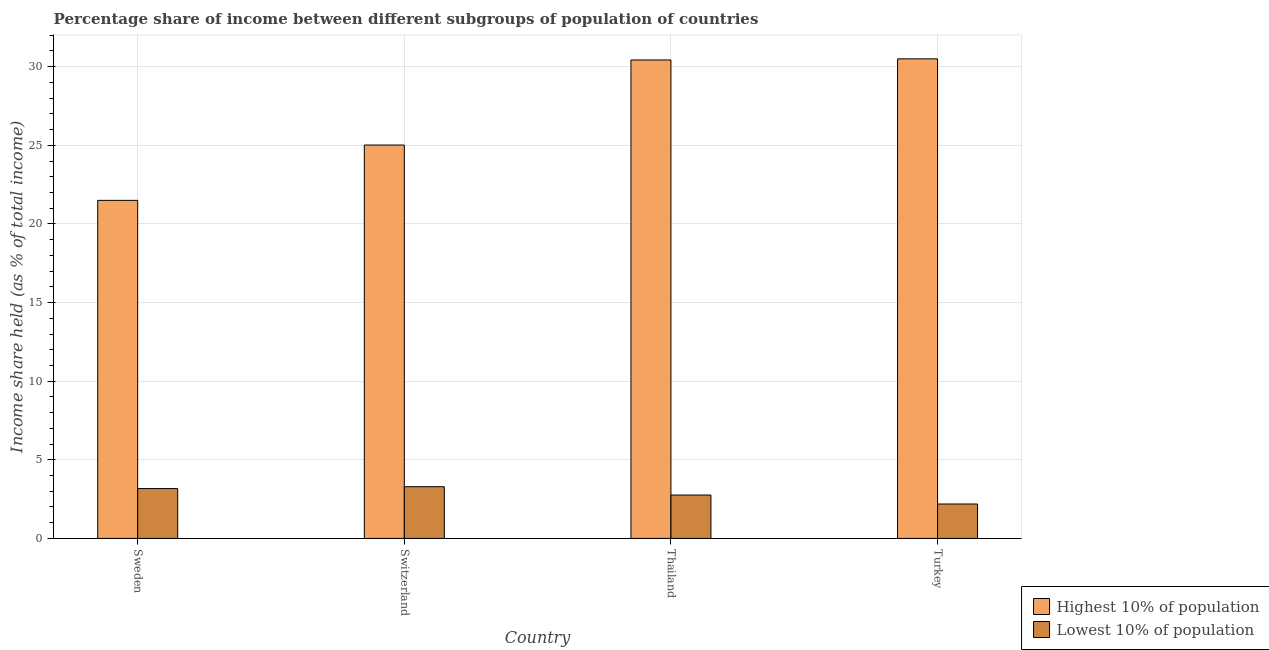Are the number of bars on each tick of the X-axis equal?
Your response must be concise. Yes. How many bars are there on the 2nd tick from the left?
Make the answer very short. 2. How many bars are there on the 3rd tick from the right?
Keep it short and to the point. 2. In how many cases, is the number of bars for a given country not equal to the number of legend labels?
Your answer should be compact. 0. What is the income share held by highest 10% of the population in Turkey?
Provide a short and direct response. 30.5. Across all countries, what is the maximum income share held by highest 10% of the population?
Provide a succinct answer. 30.5. Across all countries, what is the minimum income share held by highest 10% of the population?
Offer a very short reply. 21.5. In which country was the income share held by lowest 10% of the population minimum?
Your response must be concise. Turkey. What is the total income share held by lowest 10% of the population in the graph?
Ensure brevity in your answer.  11.41. What is the difference between the income share held by highest 10% of the population in Switzerland and that in Thailand?
Give a very brief answer. -5.41. What is the difference between the income share held by lowest 10% of the population in Switzerland and the income share held by highest 10% of the population in Turkey?
Your answer should be very brief. -27.21. What is the average income share held by highest 10% of the population per country?
Provide a succinct answer. 26.86. What is the difference between the income share held by lowest 10% of the population and income share held by highest 10% of the population in Sweden?
Offer a terse response. -18.33. In how many countries, is the income share held by lowest 10% of the population greater than 19 %?
Keep it short and to the point. 0. What is the ratio of the income share held by lowest 10% of the population in Sweden to that in Turkey?
Keep it short and to the point. 1.45. What is the difference between the highest and the second highest income share held by lowest 10% of the population?
Make the answer very short. 0.12. In how many countries, is the income share held by lowest 10% of the population greater than the average income share held by lowest 10% of the population taken over all countries?
Your answer should be very brief. 2. Is the sum of the income share held by lowest 10% of the population in Thailand and Turkey greater than the maximum income share held by highest 10% of the population across all countries?
Ensure brevity in your answer.  No. What does the 1st bar from the left in Sweden represents?
Ensure brevity in your answer.  Highest 10% of population. What does the 1st bar from the right in Sweden represents?
Your answer should be compact. Lowest 10% of population. How many countries are there in the graph?
Provide a succinct answer. 4. Are the values on the major ticks of Y-axis written in scientific E-notation?
Your answer should be compact. No. What is the title of the graph?
Provide a succinct answer. Percentage share of income between different subgroups of population of countries. Does "Secondary education" appear as one of the legend labels in the graph?
Your answer should be compact. No. What is the label or title of the X-axis?
Keep it short and to the point. Country. What is the label or title of the Y-axis?
Offer a very short reply. Income share held (as % of total income). What is the Income share held (as % of total income) of Highest 10% of population in Sweden?
Ensure brevity in your answer.  21.5. What is the Income share held (as % of total income) in Lowest 10% of population in Sweden?
Your answer should be very brief. 3.17. What is the Income share held (as % of total income) in Highest 10% of population in Switzerland?
Keep it short and to the point. 25.02. What is the Income share held (as % of total income) in Lowest 10% of population in Switzerland?
Give a very brief answer. 3.29. What is the Income share held (as % of total income) in Highest 10% of population in Thailand?
Your response must be concise. 30.43. What is the Income share held (as % of total income) of Lowest 10% of population in Thailand?
Your answer should be compact. 2.76. What is the Income share held (as % of total income) in Highest 10% of population in Turkey?
Your answer should be very brief. 30.5. What is the Income share held (as % of total income) of Lowest 10% of population in Turkey?
Offer a terse response. 2.19. Across all countries, what is the maximum Income share held (as % of total income) in Highest 10% of population?
Make the answer very short. 30.5. Across all countries, what is the maximum Income share held (as % of total income) of Lowest 10% of population?
Ensure brevity in your answer.  3.29. Across all countries, what is the minimum Income share held (as % of total income) in Highest 10% of population?
Offer a terse response. 21.5. Across all countries, what is the minimum Income share held (as % of total income) in Lowest 10% of population?
Give a very brief answer. 2.19. What is the total Income share held (as % of total income) in Highest 10% of population in the graph?
Keep it short and to the point. 107.45. What is the total Income share held (as % of total income) of Lowest 10% of population in the graph?
Make the answer very short. 11.41. What is the difference between the Income share held (as % of total income) in Highest 10% of population in Sweden and that in Switzerland?
Provide a succinct answer. -3.52. What is the difference between the Income share held (as % of total income) of Lowest 10% of population in Sweden and that in Switzerland?
Make the answer very short. -0.12. What is the difference between the Income share held (as % of total income) of Highest 10% of population in Sweden and that in Thailand?
Your answer should be very brief. -8.93. What is the difference between the Income share held (as % of total income) in Lowest 10% of population in Sweden and that in Thailand?
Your answer should be compact. 0.41. What is the difference between the Income share held (as % of total income) of Highest 10% of population in Switzerland and that in Thailand?
Make the answer very short. -5.41. What is the difference between the Income share held (as % of total income) in Lowest 10% of population in Switzerland and that in Thailand?
Keep it short and to the point. 0.53. What is the difference between the Income share held (as % of total income) in Highest 10% of population in Switzerland and that in Turkey?
Keep it short and to the point. -5.48. What is the difference between the Income share held (as % of total income) of Highest 10% of population in Thailand and that in Turkey?
Provide a succinct answer. -0.07. What is the difference between the Income share held (as % of total income) in Lowest 10% of population in Thailand and that in Turkey?
Ensure brevity in your answer.  0.57. What is the difference between the Income share held (as % of total income) of Highest 10% of population in Sweden and the Income share held (as % of total income) of Lowest 10% of population in Switzerland?
Keep it short and to the point. 18.21. What is the difference between the Income share held (as % of total income) of Highest 10% of population in Sweden and the Income share held (as % of total income) of Lowest 10% of population in Thailand?
Your answer should be very brief. 18.74. What is the difference between the Income share held (as % of total income) of Highest 10% of population in Sweden and the Income share held (as % of total income) of Lowest 10% of population in Turkey?
Your answer should be very brief. 19.31. What is the difference between the Income share held (as % of total income) of Highest 10% of population in Switzerland and the Income share held (as % of total income) of Lowest 10% of population in Thailand?
Your response must be concise. 22.26. What is the difference between the Income share held (as % of total income) in Highest 10% of population in Switzerland and the Income share held (as % of total income) in Lowest 10% of population in Turkey?
Your answer should be compact. 22.83. What is the difference between the Income share held (as % of total income) in Highest 10% of population in Thailand and the Income share held (as % of total income) in Lowest 10% of population in Turkey?
Give a very brief answer. 28.24. What is the average Income share held (as % of total income) in Highest 10% of population per country?
Your answer should be very brief. 26.86. What is the average Income share held (as % of total income) in Lowest 10% of population per country?
Give a very brief answer. 2.85. What is the difference between the Income share held (as % of total income) in Highest 10% of population and Income share held (as % of total income) in Lowest 10% of population in Sweden?
Give a very brief answer. 18.33. What is the difference between the Income share held (as % of total income) in Highest 10% of population and Income share held (as % of total income) in Lowest 10% of population in Switzerland?
Offer a terse response. 21.73. What is the difference between the Income share held (as % of total income) of Highest 10% of population and Income share held (as % of total income) of Lowest 10% of population in Thailand?
Offer a very short reply. 27.67. What is the difference between the Income share held (as % of total income) of Highest 10% of population and Income share held (as % of total income) of Lowest 10% of population in Turkey?
Your response must be concise. 28.31. What is the ratio of the Income share held (as % of total income) of Highest 10% of population in Sweden to that in Switzerland?
Offer a terse response. 0.86. What is the ratio of the Income share held (as % of total income) in Lowest 10% of population in Sweden to that in Switzerland?
Your answer should be compact. 0.96. What is the ratio of the Income share held (as % of total income) in Highest 10% of population in Sweden to that in Thailand?
Your answer should be compact. 0.71. What is the ratio of the Income share held (as % of total income) in Lowest 10% of population in Sweden to that in Thailand?
Provide a succinct answer. 1.15. What is the ratio of the Income share held (as % of total income) of Highest 10% of population in Sweden to that in Turkey?
Offer a very short reply. 0.7. What is the ratio of the Income share held (as % of total income) of Lowest 10% of population in Sweden to that in Turkey?
Give a very brief answer. 1.45. What is the ratio of the Income share held (as % of total income) in Highest 10% of population in Switzerland to that in Thailand?
Provide a short and direct response. 0.82. What is the ratio of the Income share held (as % of total income) of Lowest 10% of population in Switzerland to that in Thailand?
Ensure brevity in your answer.  1.19. What is the ratio of the Income share held (as % of total income) of Highest 10% of population in Switzerland to that in Turkey?
Your response must be concise. 0.82. What is the ratio of the Income share held (as % of total income) in Lowest 10% of population in Switzerland to that in Turkey?
Make the answer very short. 1.5. What is the ratio of the Income share held (as % of total income) of Lowest 10% of population in Thailand to that in Turkey?
Your answer should be compact. 1.26. What is the difference between the highest and the second highest Income share held (as % of total income) in Highest 10% of population?
Your answer should be compact. 0.07. What is the difference between the highest and the second highest Income share held (as % of total income) in Lowest 10% of population?
Your answer should be very brief. 0.12. What is the difference between the highest and the lowest Income share held (as % of total income) in Highest 10% of population?
Provide a succinct answer. 9. 